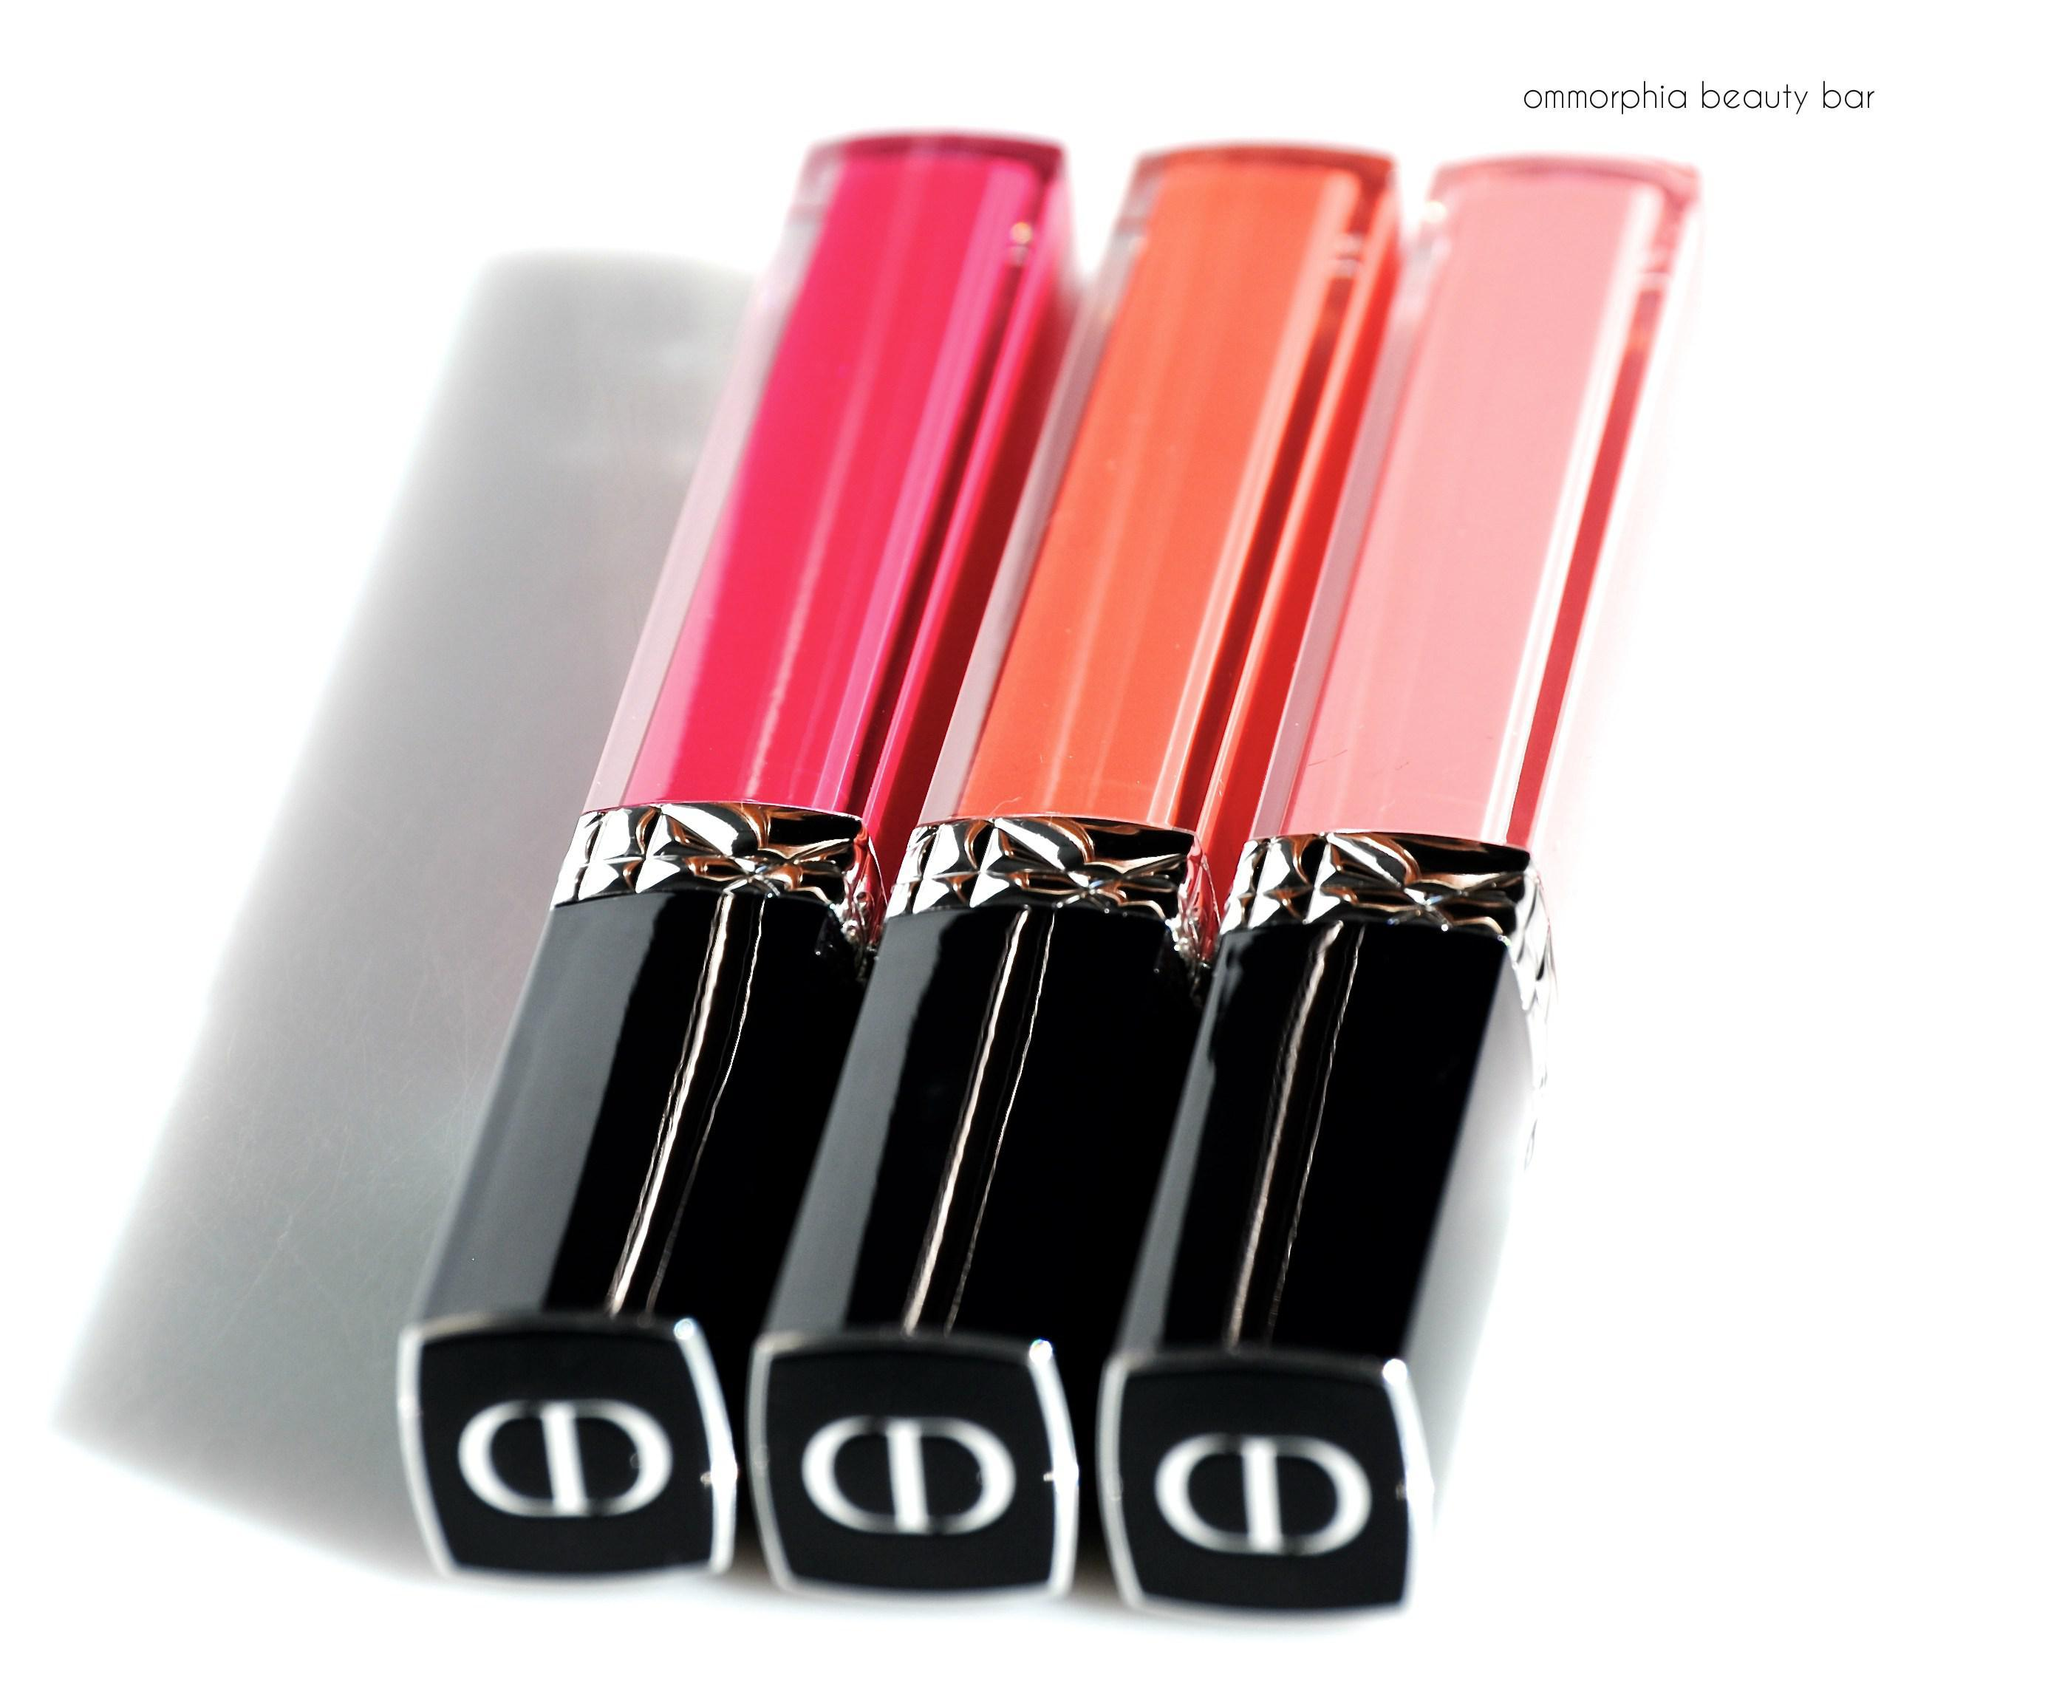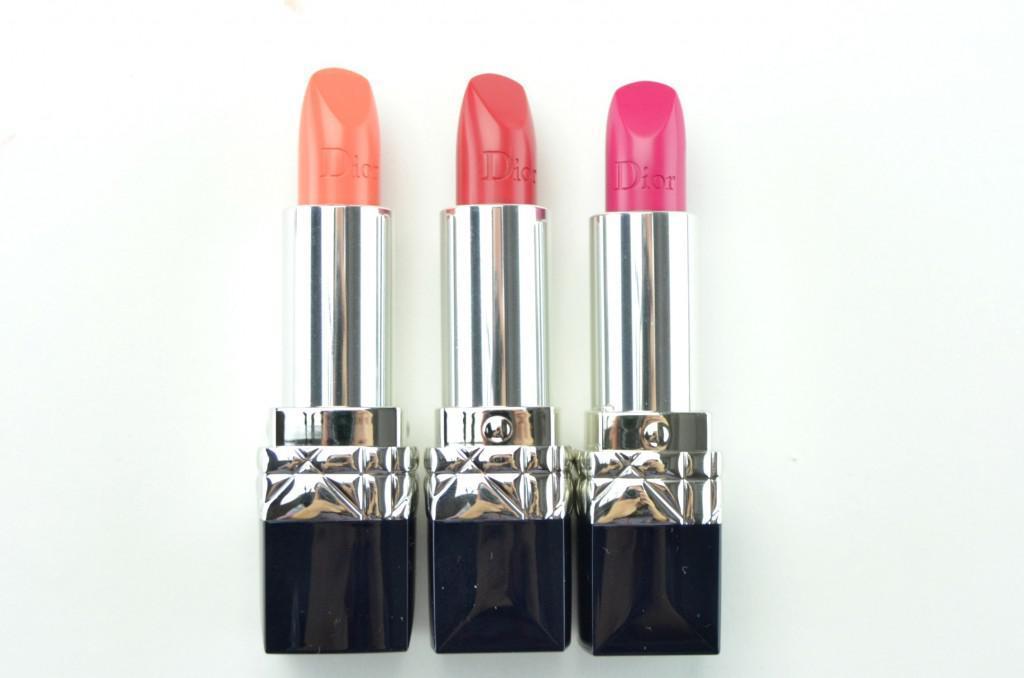The first image is the image on the left, the second image is the image on the right. Examine the images to the left and right. Is the description "There are three lipsticks in the image on the left" accurate? Answer yes or no. Yes. The first image is the image on the left, the second image is the image on the right. Evaluate the accuracy of this statement regarding the images: "A pair of lips is shown in each image.". Is it true? Answer yes or no. No. The first image is the image on the left, the second image is the image on the right. For the images displayed, is the sentence "There are at least three containers of lipstick." factually correct? Answer yes or no. Yes. 